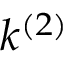<formula> <loc_0><loc_0><loc_500><loc_500>k ^ { ( 2 ) }</formula> 